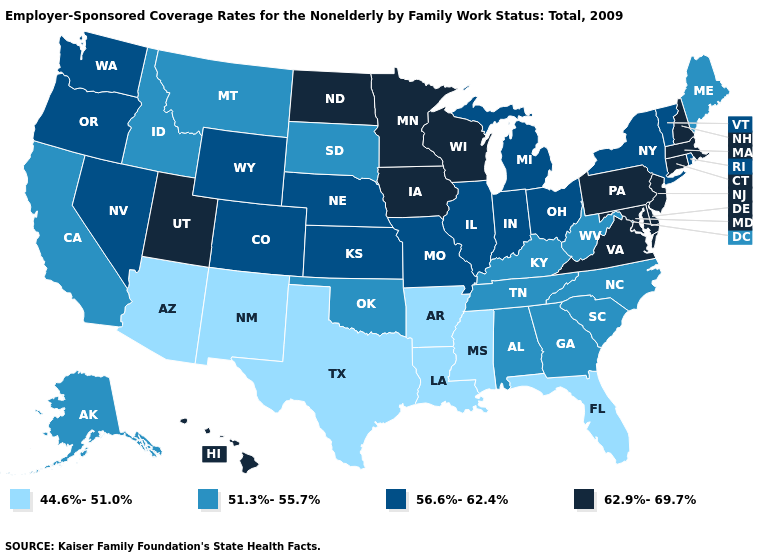What is the value of Kansas?
Short answer required. 56.6%-62.4%. Does the map have missing data?
Keep it brief. No. Among the states that border Idaho , does Washington have the lowest value?
Keep it brief. No. What is the value of Minnesota?
Be succinct. 62.9%-69.7%. Name the states that have a value in the range 51.3%-55.7%?
Write a very short answer. Alabama, Alaska, California, Georgia, Idaho, Kentucky, Maine, Montana, North Carolina, Oklahoma, South Carolina, South Dakota, Tennessee, West Virginia. Does New Hampshire have the highest value in the USA?
Keep it brief. Yes. Name the states that have a value in the range 44.6%-51.0%?
Be succinct. Arizona, Arkansas, Florida, Louisiana, Mississippi, New Mexico, Texas. Does the map have missing data?
Be succinct. No. What is the highest value in the USA?
Concise answer only. 62.9%-69.7%. What is the value of Oklahoma?
Concise answer only. 51.3%-55.7%. What is the value of Maine?
Be succinct. 51.3%-55.7%. Among the states that border Michigan , which have the highest value?
Short answer required. Wisconsin. What is the lowest value in the USA?
Be succinct. 44.6%-51.0%. Name the states that have a value in the range 56.6%-62.4%?
Concise answer only. Colorado, Illinois, Indiana, Kansas, Michigan, Missouri, Nebraska, Nevada, New York, Ohio, Oregon, Rhode Island, Vermont, Washington, Wyoming. 